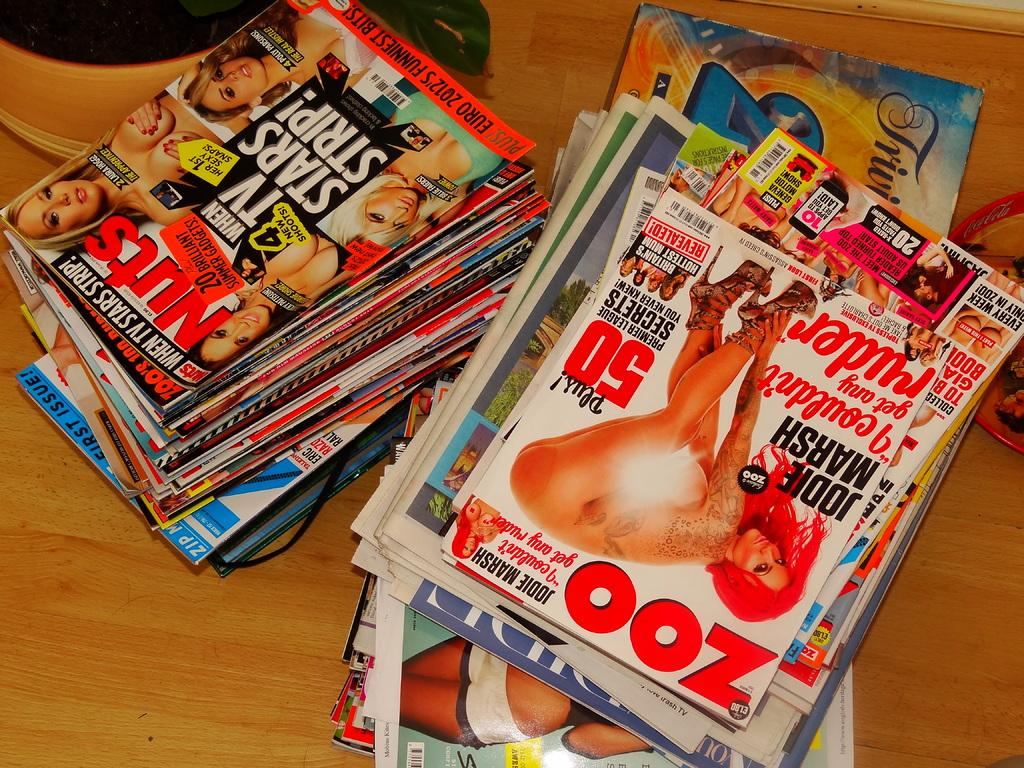Provide a one-sentence caption for the provided image. A large pile of lads mags with Zoo being ontop. 